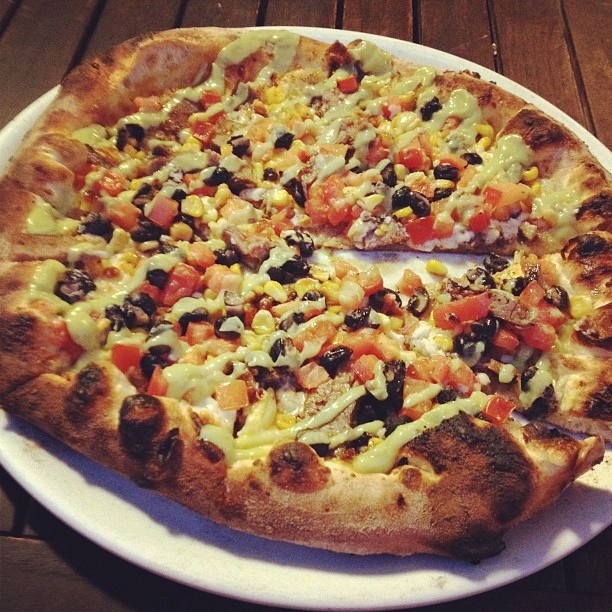Describe the objects in this image and their specific colors. I can see pizza in black, maroon, tan, and brown tones and dining table in black, brown, and darkgray tones in this image. 